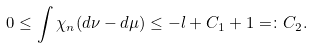<formula> <loc_0><loc_0><loc_500><loc_500>0 \leq \int \chi _ { n } ( d \nu - d \mu ) \leq - l + C _ { 1 } + 1 = \colon C _ { 2 } .</formula> 